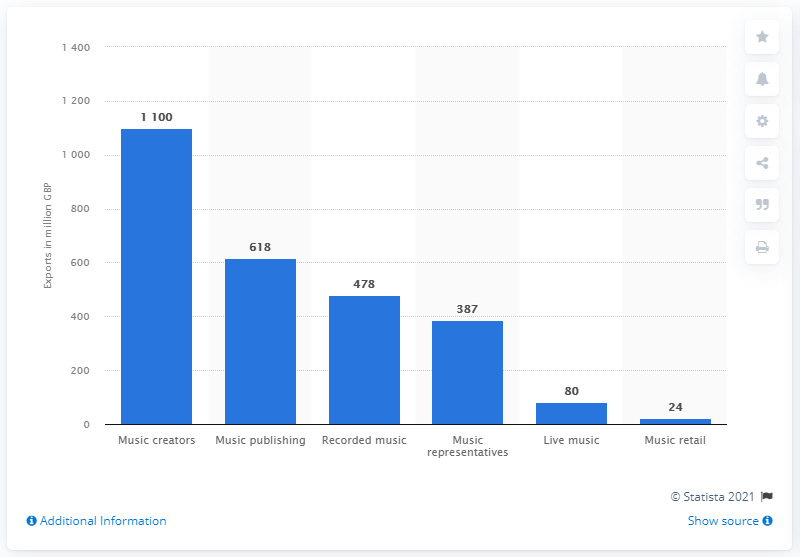Draw attention to some important aspects in this diagram. The estimated value of British music publishing exports in 2018 was 618 million pounds. 